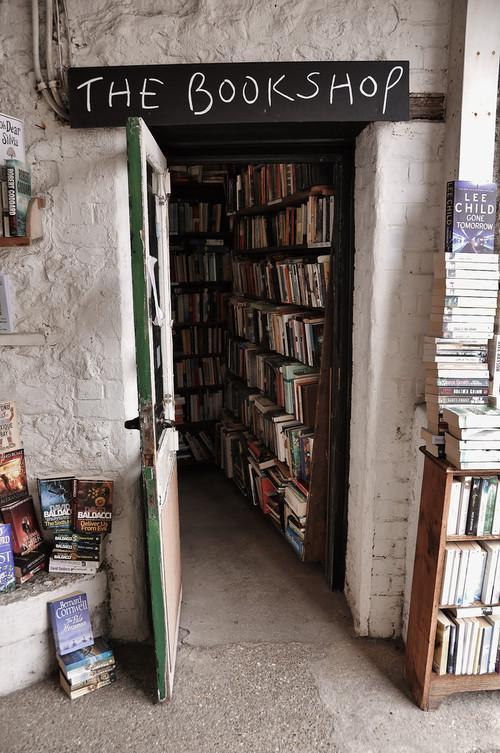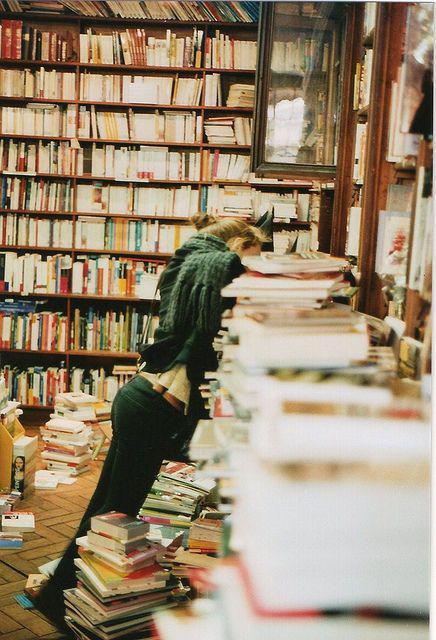The first image is the image on the left, the second image is the image on the right. Analyze the images presented: Is the assertion "The right image contains an outside view of a storefront." valid? Answer yes or no. No. The first image is the image on the left, the second image is the image on the right. For the images displayed, is the sentence "In this book store there is at least one person looking at  books from the shelve." factually correct? Answer yes or no. Yes. 